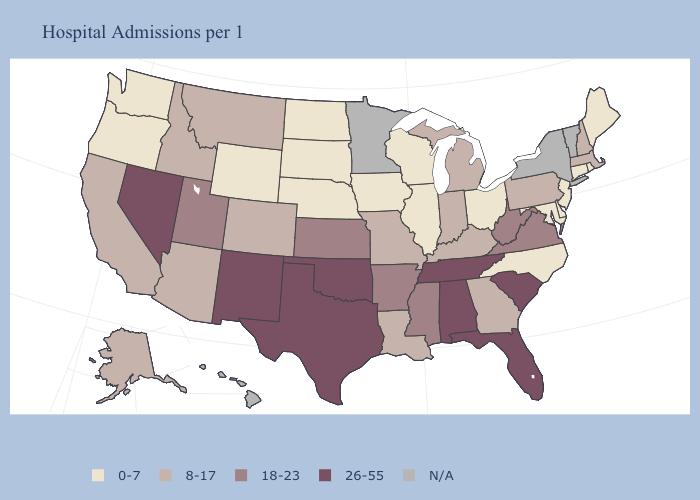Name the states that have a value in the range N/A?
Quick response, please. Hawaii, Minnesota, New York, Vermont. Does the first symbol in the legend represent the smallest category?
Concise answer only. Yes. Name the states that have a value in the range 18-23?
Write a very short answer. Arkansas, Kansas, Mississippi, Utah, Virginia, West Virginia. Name the states that have a value in the range 26-55?
Be succinct. Alabama, Florida, Nevada, New Mexico, Oklahoma, South Carolina, Tennessee, Texas. Name the states that have a value in the range 26-55?
Short answer required. Alabama, Florida, Nevada, New Mexico, Oklahoma, South Carolina, Tennessee, Texas. What is the value of New York?
Short answer required. N/A. Name the states that have a value in the range N/A?
Keep it brief. Hawaii, Minnesota, New York, Vermont. What is the highest value in states that border Washington?
Quick response, please. 8-17. What is the value of Connecticut?
Short answer required. 0-7. What is the lowest value in states that border Pennsylvania?
Give a very brief answer. 0-7. Which states have the lowest value in the MidWest?
Give a very brief answer. Illinois, Iowa, Nebraska, North Dakota, Ohio, South Dakota, Wisconsin. Name the states that have a value in the range 0-7?
Write a very short answer. Connecticut, Delaware, Illinois, Iowa, Maine, Maryland, Nebraska, New Jersey, North Carolina, North Dakota, Ohio, Oregon, Rhode Island, South Dakota, Washington, Wisconsin, Wyoming. Is the legend a continuous bar?
Short answer required. No. What is the value of Nebraska?
Be succinct. 0-7. 